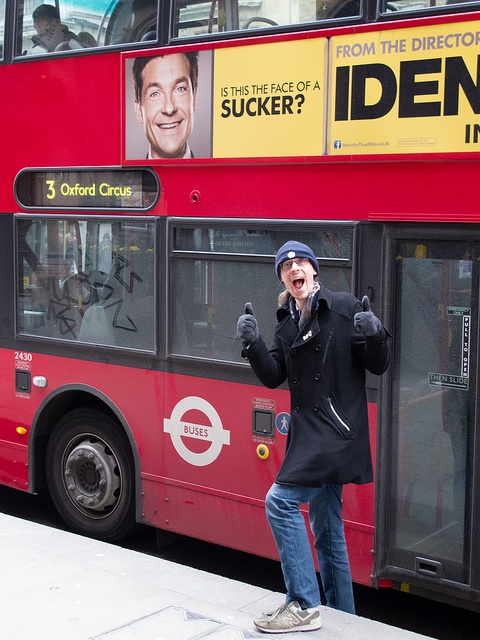Describe the objects in this image and their specific colors. I can see bus in lightblue, gray, black, and brown tones and people in lightblue, black, and gray tones in this image. 